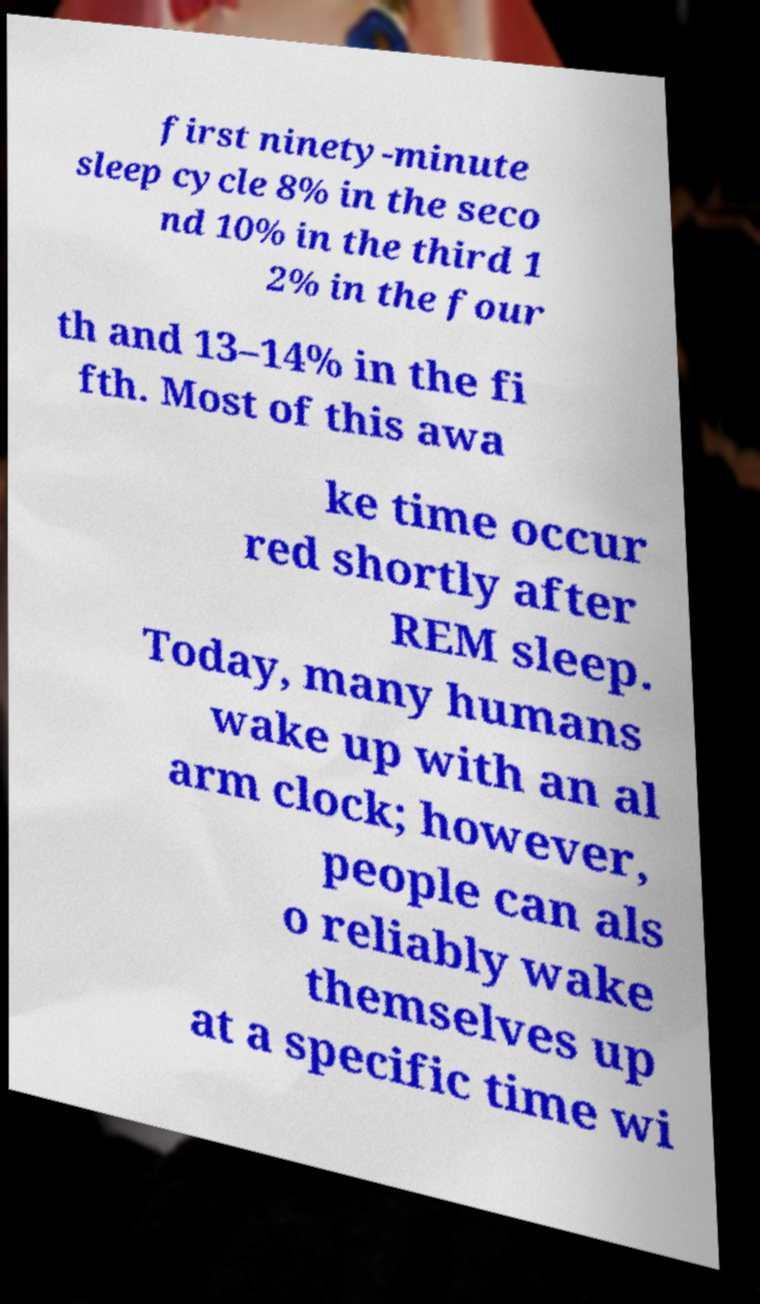Can you read and provide the text displayed in the image?This photo seems to have some interesting text. Can you extract and type it out for me? first ninety-minute sleep cycle 8% in the seco nd 10% in the third 1 2% in the four th and 13–14% in the fi fth. Most of this awa ke time occur red shortly after REM sleep. Today, many humans wake up with an al arm clock; however, people can als o reliably wake themselves up at a specific time wi 